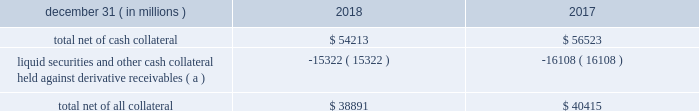Jpmorgan chase & co./2018 form 10-k 117 lending-related commitments the firm uses lending-related financial instruments , such as commitments ( including revolving credit facilities ) and guarantees , to address the financing needs of its clients .
The contractual amounts of these financial instruments represent the maximum possible credit risk should the clients draw down on these commitments or the firm fulfill its obligations under these guarantees , and the clients subsequently fail to perform according to the terms of these contracts .
Most of these commitments and guarantees are refinanced , extended , cancelled , or expire without being drawn upon or a default occurring .
In the firm 2019s view , the total contractual amount of these wholesale lending-related commitments is not representative of the firm 2019s expected future credit exposure or funding requirements .
For further information on wholesale lending-related commitments , refer to note 27 .
Clearing services the firm provides clearing services for clients entering into certain securities and derivative contracts .
Through the provision of these services the firm is exposed to the risk of non-performance by its clients and may be required to share in losses incurred by ccps .
Where possible , the firm seeks to mitigate its credit risk to its clients through the collection of adequate margin at inception and throughout the life of the transactions and can also cease provision of clearing services if clients do not adhere to their obligations under the clearing agreement .
For further discussion of clearing services , refer to note 27 .
Derivative contracts derivatives enable clients and counterparties to manage risks including credit risk and risks arising from fluctuations in interest rates , foreign exchange , equities , and commodities .
The firm makes markets in derivatives in order to meet these needs and uses derivatives to manage certain risks associated with net open risk positions from its market-making activities , including the counterparty credit risk arising from derivative receivables .
The firm also uses derivative instruments to manage its own credit and other market risk exposure .
The nature of the counterparty and the settlement mechanism of the derivative affect the credit risk to which the firm is exposed .
For otc derivatives the firm is exposed to the credit risk of the derivative counterparty .
For exchange-traded derivatives ( 201cetd 201d ) , such as futures and options , and 201ccleared 201d over-the-counter ( 201cotc-cleared 201d ) derivatives , the firm is generally exposed to the credit risk of the relevant ccp .
Where possible , the firm seeks to mitigate its credit risk exposures arising from derivative contracts through the use of legally enforceable master netting arrangements and collateral agreements .
For a further discussion of derivative contracts , counterparties and settlement types , refer to note 5 .
The table summarizes the net derivative receivables for the periods presented .
Derivative receivables .
( a ) includes collateral related to derivative instruments where appropriate legal opinions have not been either sought or obtained with respect to master netting agreements .
The fair value of derivative receivables reported on the consolidated balance sheets were $ 54.2 billion and $ 56.5 billion at december 31 , 2018 and 2017 , respectively .
Derivative receivables represent the fair value of the derivative contracts after giving effect to legally enforceable master netting agreements and cash collateral held by the firm .
However , in management 2019s view , the appropriate measure of current credit risk should also take into consideration additional liquid securities ( primarily u.s .
Government and agency securities and other group of seven nations ( 201cg7 201d ) government securities ) and other cash collateral held by the firm aggregating $ 15.3 billion and $ 16.1 billion at december 31 , 2018 and 2017 , respectively , that may be used as security when the fair value of the client 2019s exposure is in the firm 2019s favor .
In addition to the collateral described in the preceding paragraph , the firm also holds additional collateral ( primarily cash , g7 government securities , other liquid government-agency and guaranteed securities , and corporate debt and equity securities ) delivered by clients at the initiation of transactions , as well as collateral related to contracts that have a non-daily call frequency and collateral that the firm has agreed to return but has not yet settled as of the reporting date .
Although this collateral does not reduce the balances and is not included in the table above , it is available as security against potential exposure that could arise should the fair value of the client 2019s derivative contracts move in the firm 2019s favor .
The derivative receivables fair value , net of all collateral , also does not include other credit enhancements , such as letters of credit .
For additional information on the firm 2019s use of collateral agreements , refer to note 5 .
While useful as a current view of credit exposure , the net fair value of the derivative receivables does not capture the potential future variability of that credit exposure .
To capture the potential future variability of credit exposure , the firm calculates , on a client-by-client basis , three measures of potential derivatives-related credit loss : peak , derivative risk equivalent ( 201cdre 201d ) , and average exposure ( 201cavg 201d ) .
These measures all incorporate netting and collateral benefits , where applicable .
Peak represents a conservative measure of potential exposure to a counterparty calculated in a manner that is broadly equivalent to a 97.5% ( 97.5 % ) confidence level over the life of the transaction .
Peak is the primary measure used by the firm for setting of credit limits for derivative contracts , senior management reporting and derivatives exposure management .
Dre exposure is a measure that expresses the risk of derivative exposure on a basis intended to be .
What is the amount of the decrease observed in the total net of cash collateral during 2017 and 2018 , in millions of dollars? 
Rationale: its the difference between the total net of cash collateral ( 56523 ) and ( 54213 ) in 2017 and 2018 , respectively .
Computations: (56523 - 54213)
Answer: 2310.0. Jpmorgan chase & co./2018 form 10-k 117 lending-related commitments the firm uses lending-related financial instruments , such as commitments ( including revolving credit facilities ) and guarantees , to address the financing needs of its clients .
The contractual amounts of these financial instruments represent the maximum possible credit risk should the clients draw down on these commitments or the firm fulfill its obligations under these guarantees , and the clients subsequently fail to perform according to the terms of these contracts .
Most of these commitments and guarantees are refinanced , extended , cancelled , or expire without being drawn upon or a default occurring .
In the firm 2019s view , the total contractual amount of these wholesale lending-related commitments is not representative of the firm 2019s expected future credit exposure or funding requirements .
For further information on wholesale lending-related commitments , refer to note 27 .
Clearing services the firm provides clearing services for clients entering into certain securities and derivative contracts .
Through the provision of these services the firm is exposed to the risk of non-performance by its clients and may be required to share in losses incurred by ccps .
Where possible , the firm seeks to mitigate its credit risk to its clients through the collection of adequate margin at inception and throughout the life of the transactions and can also cease provision of clearing services if clients do not adhere to their obligations under the clearing agreement .
For further discussion of clearing services , refer to note 27 .
Derivative contracts derivatives enable clients and counterparties to manage risks including credit risk and risks arising from fluctuations in interest rates , foreign exchange , equities , and commodities .
The firm makes markets in derivatives in order to meet these needs and uses derivatives to manage certain risks associated with net open risk positions from its market-making activities , including the counterparty credit risk arising from derivative receivables .
The firm also uses derivative instruments to manage its own credit and other market risk exposure .
The nature of the counterparty and the settlement mechanism of the derivative affect the credit risk to which the firm is exposed .
For otc derivatives the firm is exposed to the credit risk of the derivative counterparty .
For exchange-traded derivatives ( 201cetd 201d ) , such as futures and options , and 201ccleared 201d over-the-counter ( 201cotc-cleared 201d ) derivatives , the firm is generally exposed to the credit risk of the relevant ccp .
Where possible , the firm seeks to mitigate its credit risk exposures arising from derivative contracts through the use of legally enforceable master netting arrangements and collateral agreements .
For a further discussion of derivative contracts , counterparties and settlement types , refer to note 5 .
The table summarizes the net derivative receivables for the periods presented .
Derivative receivables .
( a ) includes collateral related to derivative instruments where appropriate legal opinions have not been either sought or obtained with respect to master netting agreements .
The fair value of derivative receivables reported on the consolidated balance sheets were $ 54.2 billion and $ 56.5 billion at december 31 , 2018 and 2017 , respectively .
Derivative receivables represent the fair value of the derivative contracts after giving effect to legally enforceable master netting agreements and cash collateral held by the firm .
However , in management 2019s view , the appropriate measure of current credit risk should also take into consideration additional liquid securities ( primarily u.s .
Government and agency securities and other group of seven nations ( 201cg7 201d ) government securities ) and other cash collateral held by the firm aggregating $ 15.3 billion and $ 16.1 billion at december 31 , 2018 and 2017 , respectively , that may be used as security when the fair value of the client 2019s exposure is in the firm 2019s favor .
In addition to the collateral described in the preceding paragraph , the firm also holds additional collateral ( primarily cash , g7 government securities , other liquid government-agency and guaranteed securities , and corporate debt and equity securities ) delivered by clients at the initiation of transactions , as well as collateral related to contracts that have a non-daily call frequency and collateral that the firm has agreed to return but has not yet settled as of the reporting date .
Although this collateral does not reduce the balances and is not included in the table above , it is available as security against potential exposure that could arise should the fair value of the client 2019s derivative contracts move in the firm 2019s favor .
The derivative receivables fair value , net of all collateral , also does not include other credit enhancements , such as letters of credit .
For additional information on the firm 2019s use of collateral agreements , refer to note 5 .
While useful as a current view of credit exposure , the net fair value of the derivative receivables does not capture the potential future variability of that credit exposure .
To capture the potential future variability of credit exposure , the firm calculates , on a client-by-client basis , three measures of potential derivatives-related credit loss : peak , derivative risk equivalent ( 201cdre 201d ) , and average exposure ( 201cavg 201d ) .
These measures all incorporate netting and collateral benefits , where applicable .
Peak represents a conservative measure of potential exposure to a counterparty calculated in a manner that is broadly equivalent to a 97.5% ( 97.5 % ) confidence level over the life of the transaction .
Peak is the primary measure used by the firm for setting of credit limits for derivative contracts , senior management reporting and derivatives exposure management .
Dre exposure is a measure that expresses the risk of derivative exposure on a basis intended to be .
Did the fv of derivative receivables increase from 2017 to 2018? 
Computations: (56.5 > 54.2)
Answer: yes. 